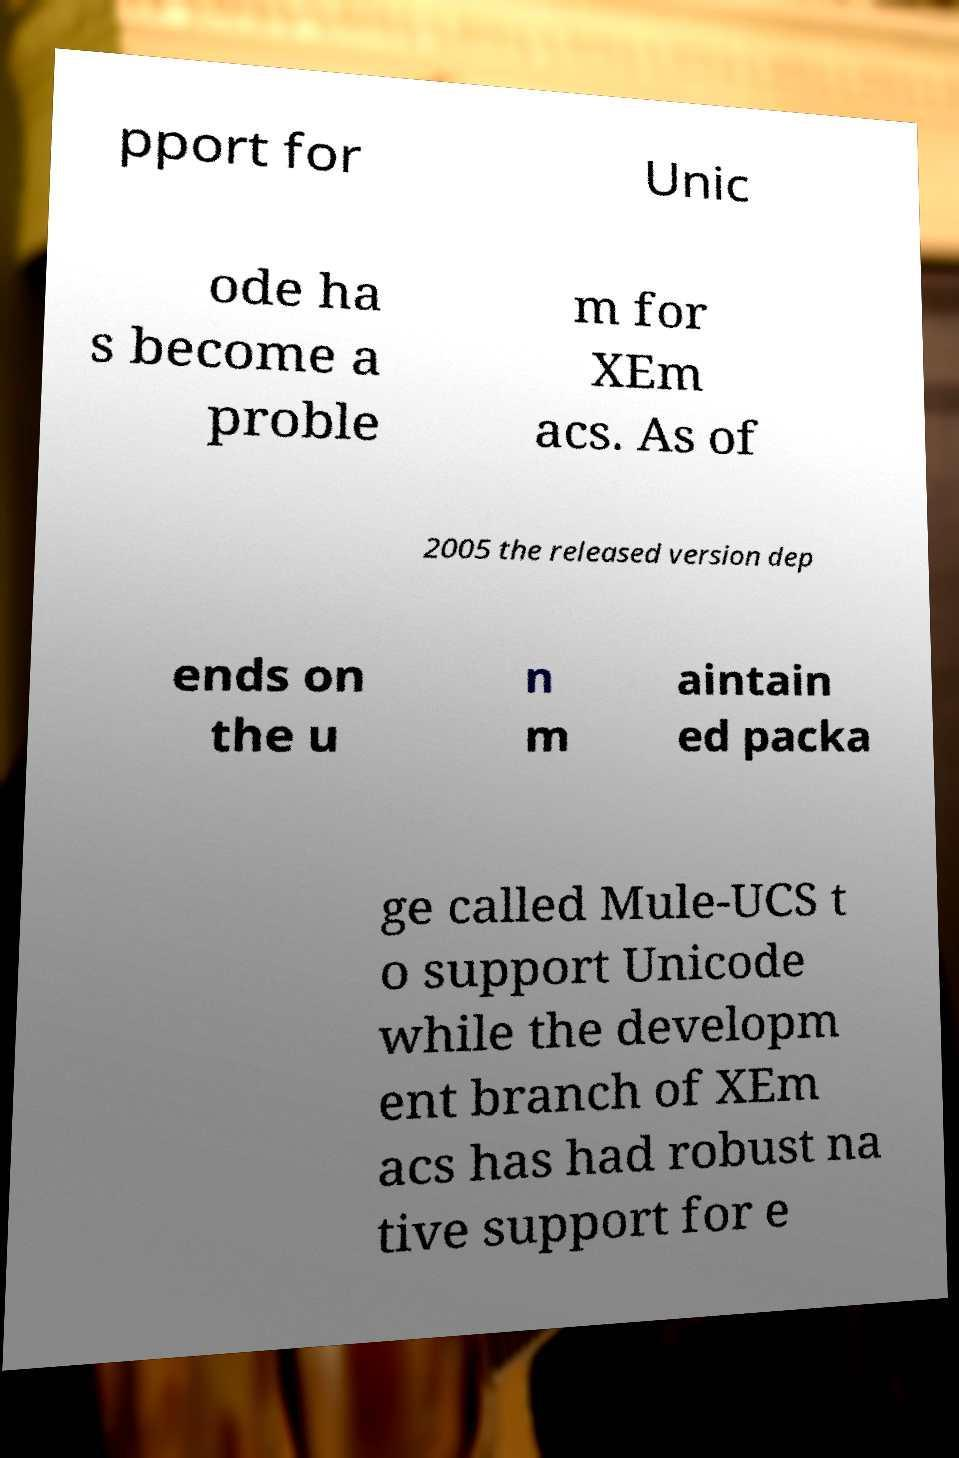Can you accurately transcribe the text from the provided image for me? pport for Unic ode ha s become a proble m for XEm acs. As of 2005 the released version dep ends on the u n m aintain ed packa ge called Mule-UCS t o support Unicode while the developm ent branch of XEm acs has had robust na tive support for e 